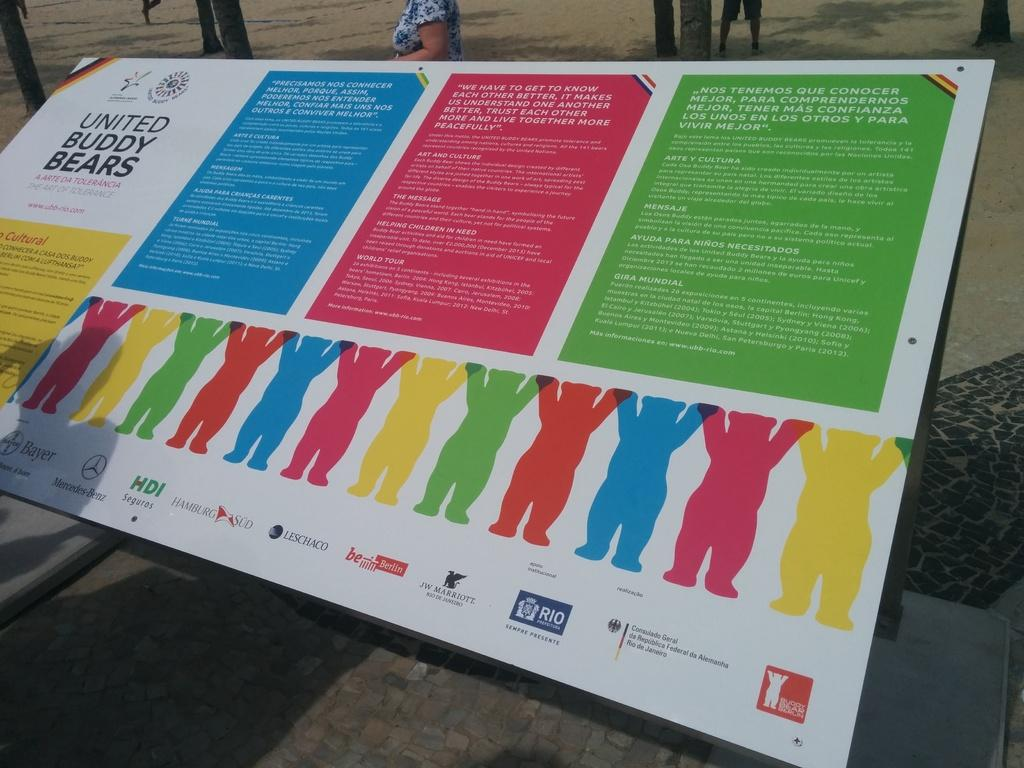Provide a one-sentence caption for the provided image. "United Buddy Bears" is listed on this informative advert. 